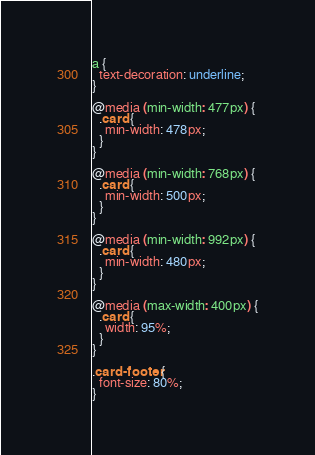<code> <loc_0><loc_0><loc_500><loc_500><_CSS_>
a {
  text-decoration: underline;
}

@media (min-width: 477px) {
  .card {
    min-width: 478px;
  }
}

@media (min-width: 768px) {
  .card {
    min-width: 500px;
  }
}

@media (min-width: 992px) {
  .card {
    min-width: 480px;
  }
}

@media (max-width: 400px) {
  .card {
    width: 95%;
  }
}

.card-footer {
  font-size: 80%;
}

</code> 